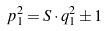Convert formula to latex. <formula><loc_0><loc_0><loc_500><loc_500>p _ { 1 } ^ { 2 } = S \cdot q _ { 1 } ^ { 2 } \pm 1</formula> 